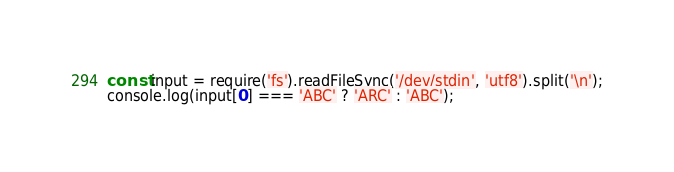<code> <loc_0><loc_0><loc_500><loc_500><_JavaScript_>const input = require('fs').readFileSync('/dev/stdin', 'utf8').split('\n');
console.log(input[0] === 'ABC' ? 'ARC' : 'ABC');</code> 